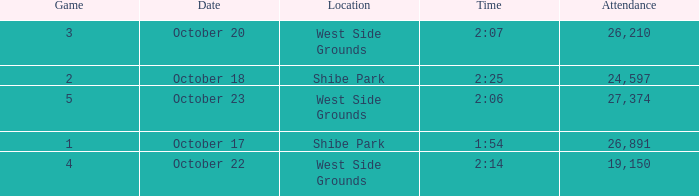For the game that was played on october 22 in west side grounds, what is the total attendance 1.0. 